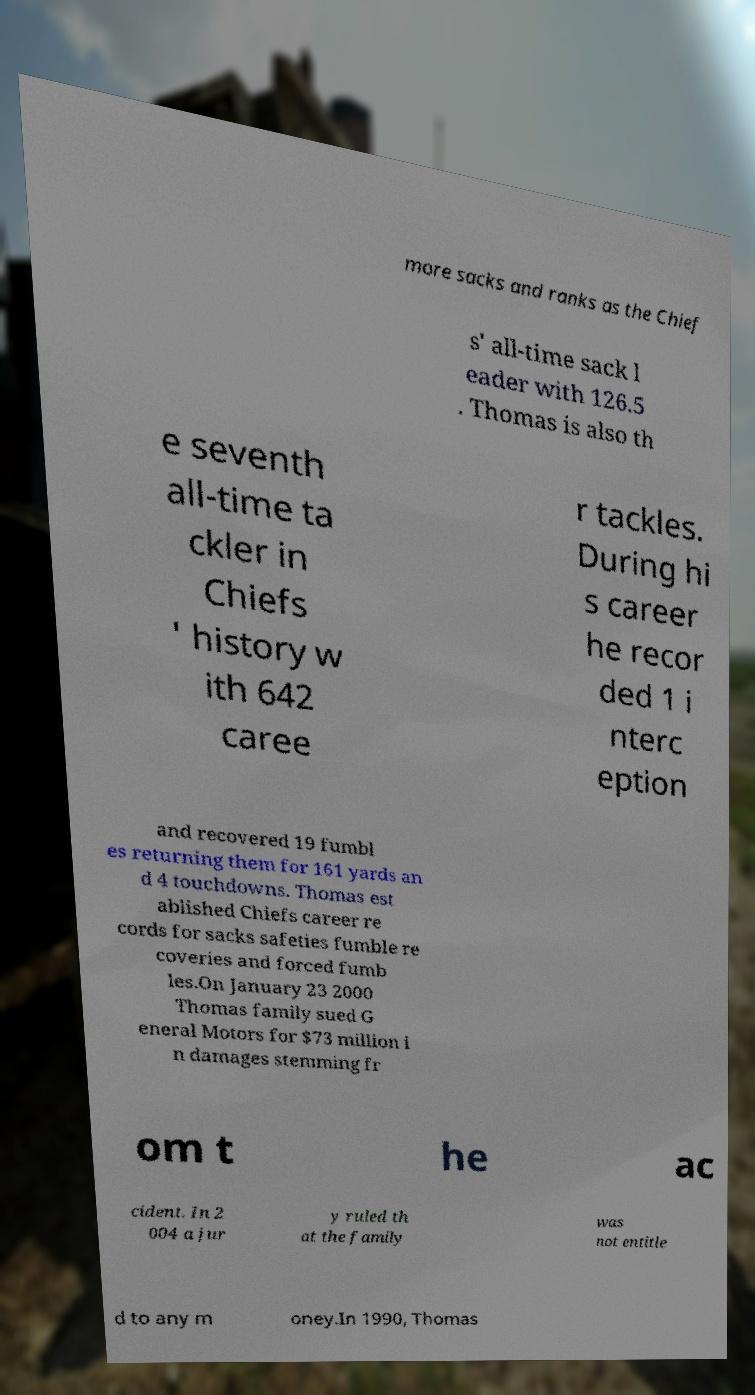Can you accurately transcribe the text from the provided image for me? more sacks and ranks as the Chief s' all-time sack l eader with 126.5 . Thomas is also th e seventh all-time ta ckler in Chiefs ' history w ith 642 caree r tackles. During hi s career he recor ded 1 i nterc eption and recovered 19 fumbl es returning them for 161 yards an d 4 touchdowns. Thomas est ablished Chiefs career re cords for sacks safeties fumble re coveries and forced fumb les.On January 23 2000 Thomas family sued G eneral Motors for $73 million i n damages stemming fr om t he ac cident. In 2 004 a jur y ruled th at the family was not entitle d to any m oney.In 1990, Thomas 